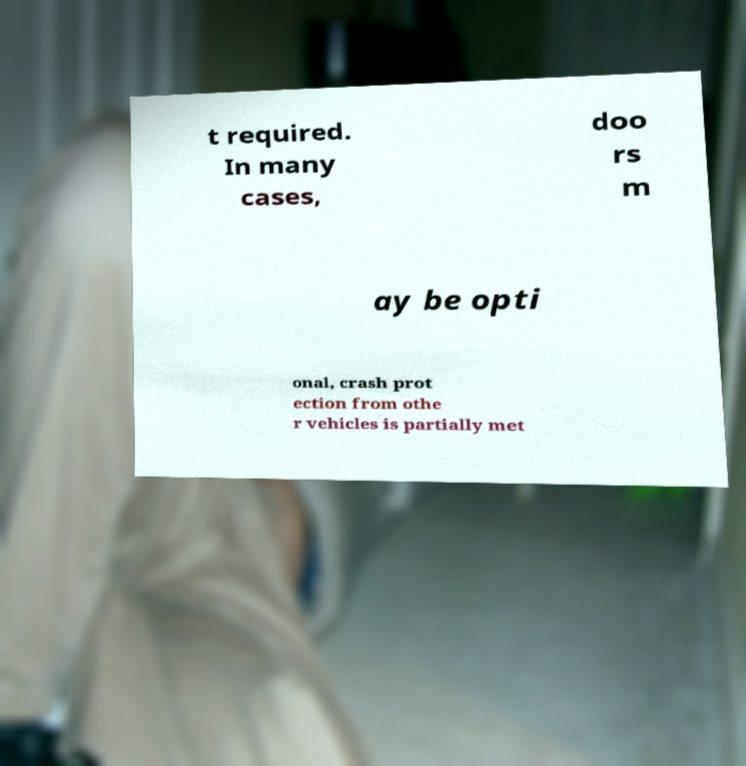Please read and relay the text visible in this image. What does it say? t required. In many cases, doo rs m ay be opti onal, crash prot ection from othe r vehicles is partially met 